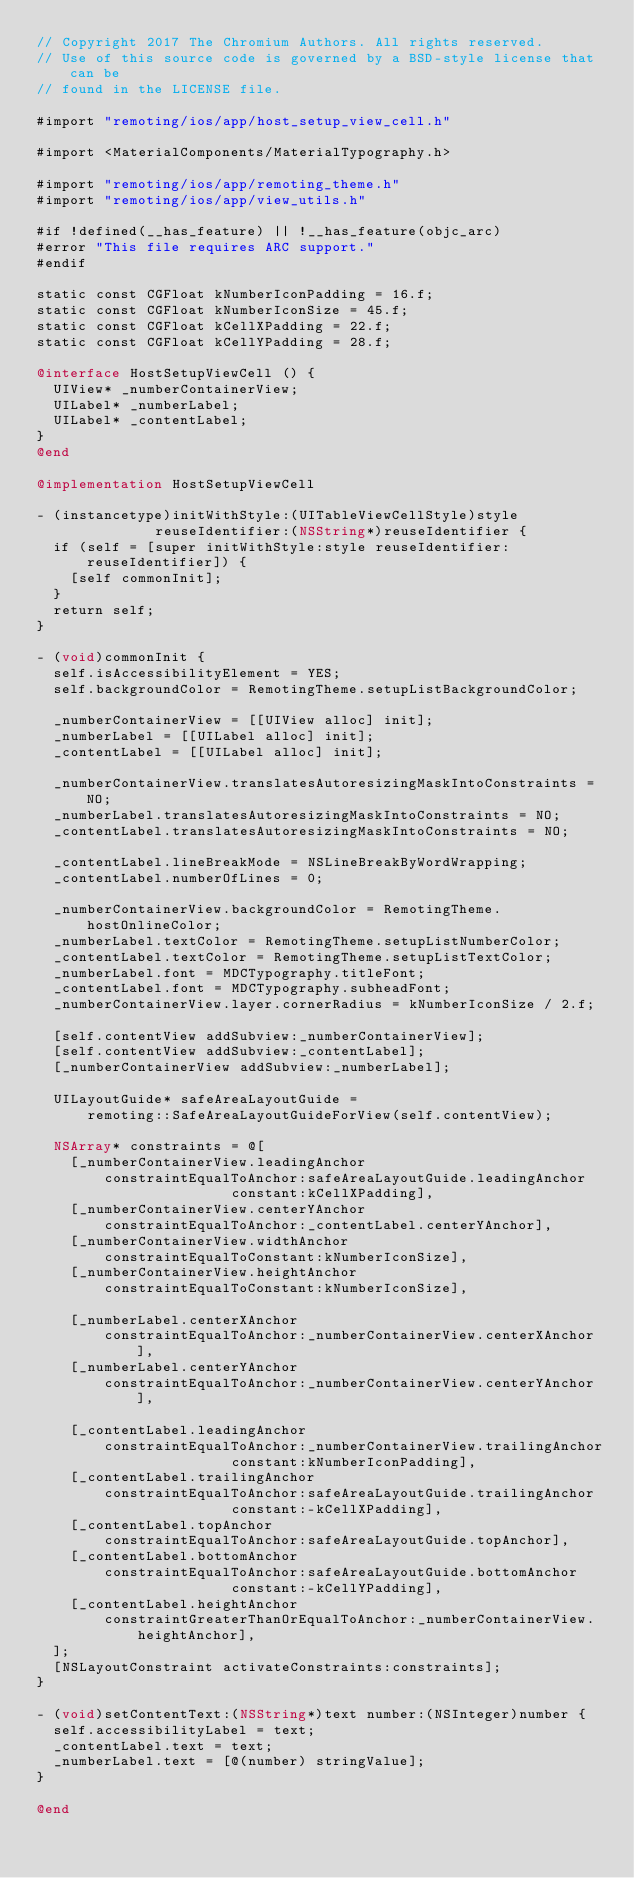<code> <loc_0><loc_0><loc_500><loc_500><_ObjectiveC_>// Copyright 2017 The Chromium Authors. All rights reserved.
// Use of this source code is governed by a BSD-style license that can be
// found in the LICENSE file.

#import "remoting/ios/app/host_setup_view_cell.h"

#import <MaterialComponents/MaterialTypography.h>

#import "remoting/ios/app/remoting_theme.h"
#import "remoting/ios/app/view_utils.h"

#if !defined(__has_feature) || !__has_feature(objc_arc)
#error "This file requires ARC support."
#endif

static const CGFloat kNumberIconPadding = 16.f;
static const CGFloat kNumberIconSize = 45.f;
static const CGFloat kCellXPadding = 22.f;
static const CGFloat kCellYPadding = 28.f;

@interface HostSetupViewCell () {
  UIView* _numberContainerView;
  UILabel* _numberLabel;
  UILabel* _contentLabel;
}
@end

@implementation HostSetupViewCell

- (instancetype)initWithStyle:(UITableViewCellStyle)style
              reuseIdentifier:(NSString*)reuseIdentifier {
  if (self = [super initWithStyle:style reuseIdentifier:reuseIdentifier]) {
    [self commonInit];
  }
  return self;
}

- (void)commonInit {
  self.isAccessibilityElement = YES;
  self.backgroundColor = RemotingTheme.setupListBackgroundColor;

  _numberContainerView = [[UIView alloc] init];
  _numberLabel = [[UILabel alloc] init];
  _contentLabel = [[UILabel alloc] init];

  _numberContainerView.translatesAutoresizingMaskIntoConstraints = NO;
  _numberLabel.translatesAutoresizingMaskIntoConstraints = NO;
  _contentLabel.translatesAutoresizingMaskIntoConstraints = NO;

  _contentLabel.lineBreakMode = NSLineBreakByWordWrapping;
  _contentLabel.numberOfLines = 0;

  _numberContainerView.backgroundColor = RemotingTheme.hostOnlineColor;
  _numberLabel.textColor = RemotingTheme.setupListNumberColor;
  _contentLabel.textColor = RemotingTheme.setupListTextColor;
  _numberLabel.font = MDCTypography.titleFont;
  _contentLabel.font = MDCTypography.subheadFont;
  _numberContainerView.layer.cornerRadius = kNumberIconSize / 2.f;

  [self.contentView addSubview:_numberContainerView];
  [self.contentView addSubview:_contentLabel];
  [_numberContainerView addSubview:_numberLabel];

  UILayoutGuide* safeAreaLayoutGuide =
      remoting::SafeAreaLayoutGuideForView(self.contentView);

  NSArray* constraints = @[
    [_numberContainerView.leadingAnchor
        constraintEqualToAnchor:safeAreaLayoutGuide.leadingAnchor
                       constant:kCellXPadding],
    [_numberContainerView.centerYAnchor
        constraintEqualToAnchor:_contentLabel.centerYAnchor],
    [_numberContainerView.widthAnchor
        constraintEqualToConstant:kNumberIconSize],
    [_numberContainerView.heightAnchor
        constraintEqualToConstant:kNumberIconSize],

    [_numberLabel.centerXAnchor
        constraintEqualToAnchor:_numberContainerView.centerXAnchor],
    [_numberLabel.centerYAnchor
        constraintEqualToAnchor:_numberContainerView.centerYAnchor],

    [_contentLabel.leadingAnchor
        constraintEqualToAnchor:_numberContainerView.trailingAnchor
                       constant:kNumberIconPadding],
    [_contentLabel.trailingAnchor
        constraintEqualToAnchor:safeAreaLayoutGuide.trailingAnchor
                       constant:-kCellXPadding],
    [_contentLabel.topAnchor
        constraintEqualToAnchor:safeAreaLayoutGuide.topAnchor],
    [_contentLabel.bottomAnchor
        constraintEqualToAnchor:safeAreaLayoutGuide.bottomAnchor
                       constant:-kCellYPadding],
    [_contentLabel.heightAnchor
        constraintGreaterThanOrEqualToAnchor:_numberContainerView.heightAnchor],
  ];
  [NSLayoutConstraint activateConstraints:constraints];
}

- (void)setContentText:(NSString*)text number:(NSInteger)number {
  self.accessibilityLabel = text;
  _contentLabel.text = text;
  _numberLabel.text = [@(number) stringValue];
}

@end
</code> 